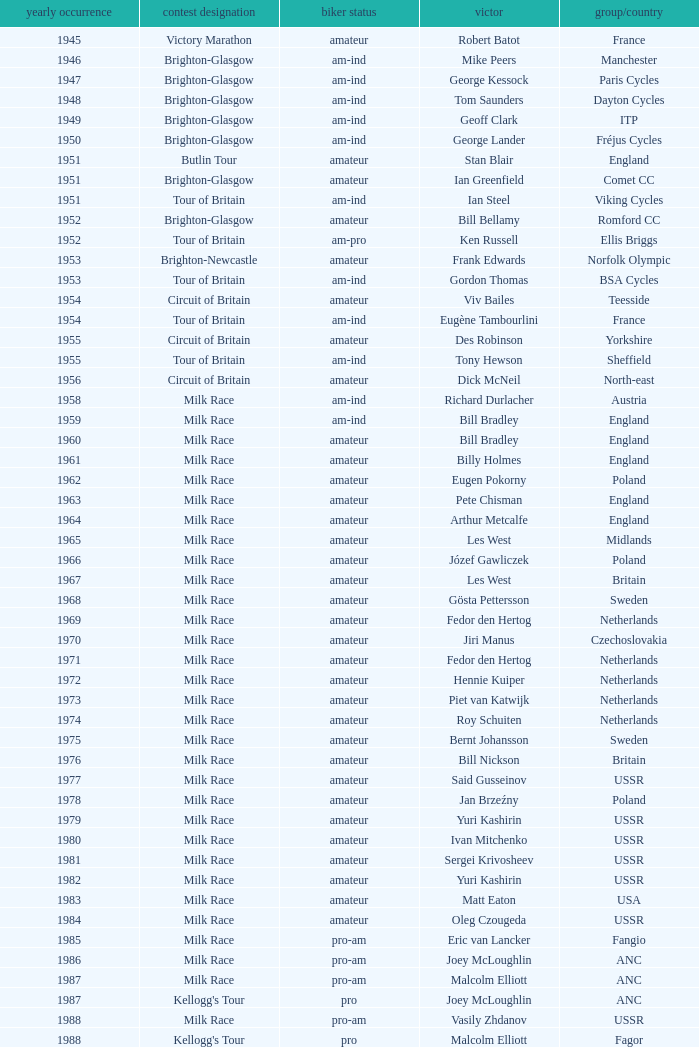What is the rider status for the 1971 netherlands team? Amateur. 